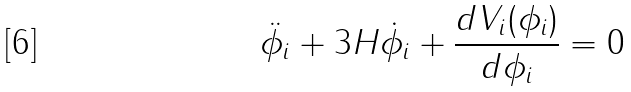<formula> <loc_0><loc_0><loc_500><loc_500>\ddot { \phi _ { i } } + 3 H \dot { \phi _ { i } } + \frac { d V _ { i } ( \phi _ { i } ) } { d \phi _ { i } } = 0</formula> 